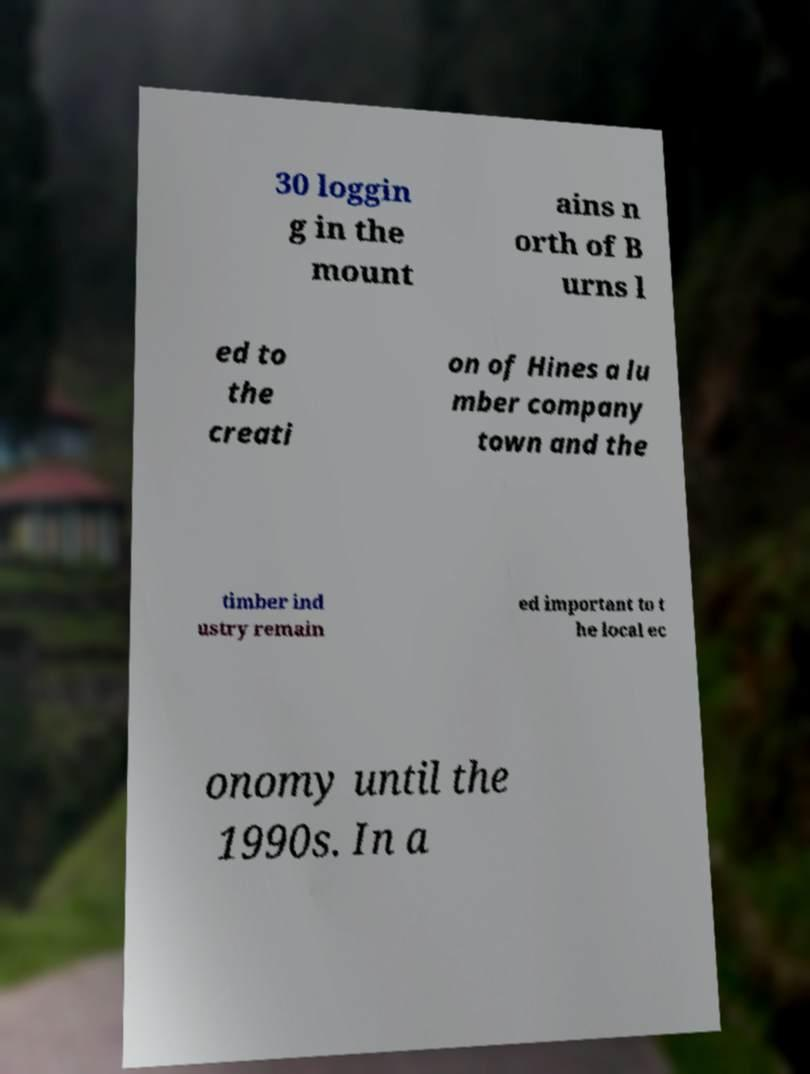I need the written content from this picture converted into text. Can you do that? 30 loggin g in the mount ains n orth of B urns l ed to the creati on of Hines a lu mber company town and the timber ind ustry remain ed important to t he local ec onomy until the 1990s. In a 